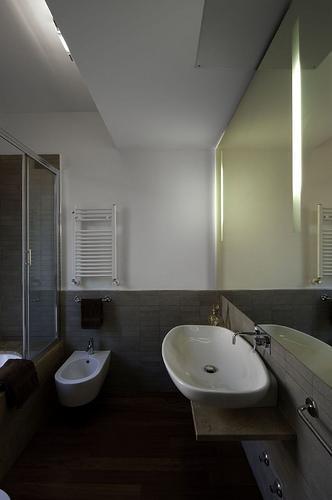How many sinks are in this picture?
Give a very brief answer. 1. How many people are stepping off of a train?
Give a very brief answer. 0. 